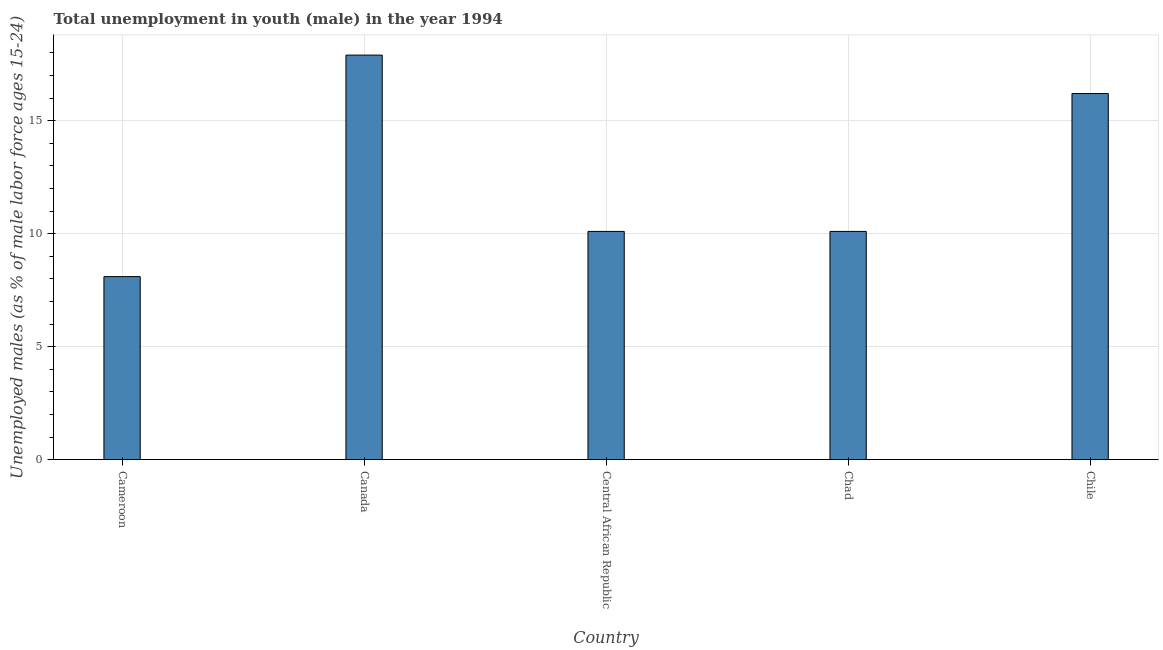Does the graph contain any zero values?
Offer a terse response. No. What is the title of the graph?
Ensure brevity in your answer.  Total unemployment in youth (male) in the year 1994. What is the label or title of the X-axis?
Offer a very short reply. Country. What is the label or title of the Y-axis?
Give a very brief answer. Unemployed males (as % of male labor force ages 15-24). What is the unemployed male youth population in Chile?
Your response must be concise. 16.2. Across all countries, what is the maximum unemployed male youth population?
Your answer should be very brief. 17.9. Across all countries, what is the minimum unemployed male youth population?
Give a very brief answer. 8.1. In which country was the unemployed male youth population maximum?
Offer a very short reply. Canada. In which country was the unemployed male youth population minimum?
Provide a succinct answer. Cameroon. What is the sum of the unemployed male youth population?
Offer a terse response. 62.4. What is the difference between the unemployed male youth population in Central African Republic and Chad?
Provide a short and direct response. 0. What is the average unemployed male youth population per country?
Provide a short and direct response. 12.48. What is the median unemployed male youth population?
Your answer should be compact. 10.1. In how many countries, is the unemployed male youth population greater than 7 %?
Provide a succinct answer. 5. What is the ratio of the unemployed male youth population in Cameroon to that in Chad?
Make the answer very short. 0.8. Is the sum of the unemployed male youth population in Canada and Central African Republic greater than the maximum unemployed male youth population across all countries?
Provide a succinct answer. Yes. In how many countries, is the unemployed male youth population greater than the average unemployed male youth population taken over all countries?
Provide a succinct answer. 2. Are all the bars in the graph horizontal?
Offer a very short reply. No. Are the values on the major ticks of Y-axis written in scientific E-notation?
Your answer should be compact. No. What is the Unemployed males (as % of male labor force ages 15-24) in Cameroon?
Make the answer very short. 8.1. What is the Unemployed males (as % of male labor force ages 15-24) of Canada?
Provide a short and direct response. 17.9. What is the Unemployed males (as % of male labor force ages 15-24) in Central African Republic?
Provide a succinct answer. 10.1. What is the Unemployed males (as % of male labor force ages 15-24) in Chad?
Ensure brevity in your answer.  10.1. What is the Unemployed males (as % of male labor force ages 15-24) in Chile?
Ensure brevity in your answer.  16.2. What is the difference between the Unemployed males (as % of male labor force ages 15-24) in Cameroon and Central African Republic?
Your response must be concise. -2. What is the difference between the Unemployed males (as % of male labor force ages 15-24) in Cameroon and Chad?
Your answer should be very brief. -2. What is the difference between the Unemployed males (as % of male labor force ages 15-24) in Cameroon and Chile?
Offer a terse response. -8.1. What is the difference between the Unemployed males (as % of male labor force ages 15-24) in Canada and Central African Republic?
Offer a terse response. 7.8. What is the difference between the Unemployed males (as % of male labor force ages 15-24) in Central African Republic and Chad?
Your answer should be very brief. 0. What is the difference between the Unemployed males (as % of male labor force ages 15-24) in Central African Republic and Chile?
Give a very brief answer. -6.1. What is the ratio of the Unemployed males (as % of male labor force ages 15-24) in Cameroon to that in Canada?
Keep it short and to the point. 0.45. What is the ratio of the Unemployed males (as % of male labor force ages 15-24) in Cameroon to that in Central African Republic?
Offer a very short reply. 0.8. What is the ratio of the Unemployed males (as % of male labor force ages 15-24) in Cameroon to that in Chad?
Offer a very short reply. 0.8. What is the ratio of the Unemployed males (as % of male labor force ages 15-24) in Canada to that in Central African Republic?
Your answer should be very brief. 1.77. What is the ratio of the Unemployed males (as % of male labor force ages 15-24) in Canada to that in Chad?
Make the answer very short. 1.77. What is the ratio of the Unemployed males (as % of male labor force ages 15-24) in Canada to that in Chile?
Keep it short and to the point. 1.1. What is the ratio of the Unemployed males (as % of male labor force ages 15-24) in Central African Republic to that in Chad?
Your answer should be very brief. 1. What is the ratio of the Unemployed males (as % of male labor force ages 15-24) in Central African Republic to that in Chile?
Your answer should be very brief. 0.62. What is the ratio of the Unemployed males (as % of male labor force ages 15-24) in Chad to that in Chile?
Keep it short and to the point. 0.62. 